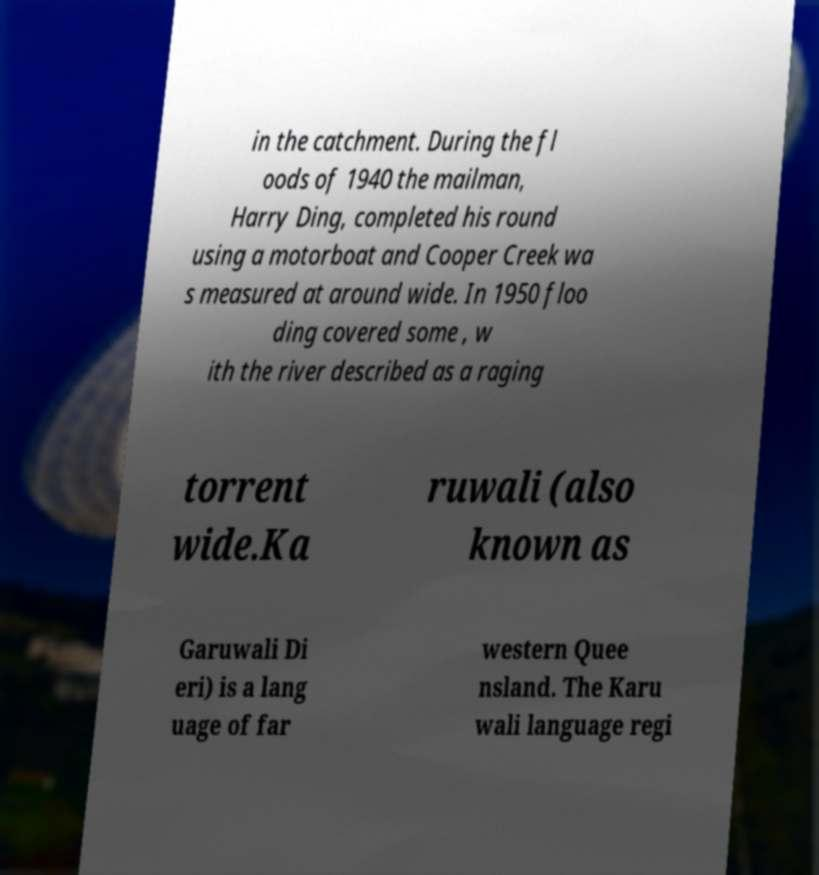Could you extract and type out the text from this image? in the catchment. During the fl oods of 1940 the mailman, Harry Ding, completed his round using a motorboat and Cooper Creek wa s measured at around wide. In 1950 floo ding covered some , w ith the river described as a raging torrent wide.Ka ruwali (also known as Garuwali Di eri) is a lang uage of far western Quee nsland. The Karu wali language regi 